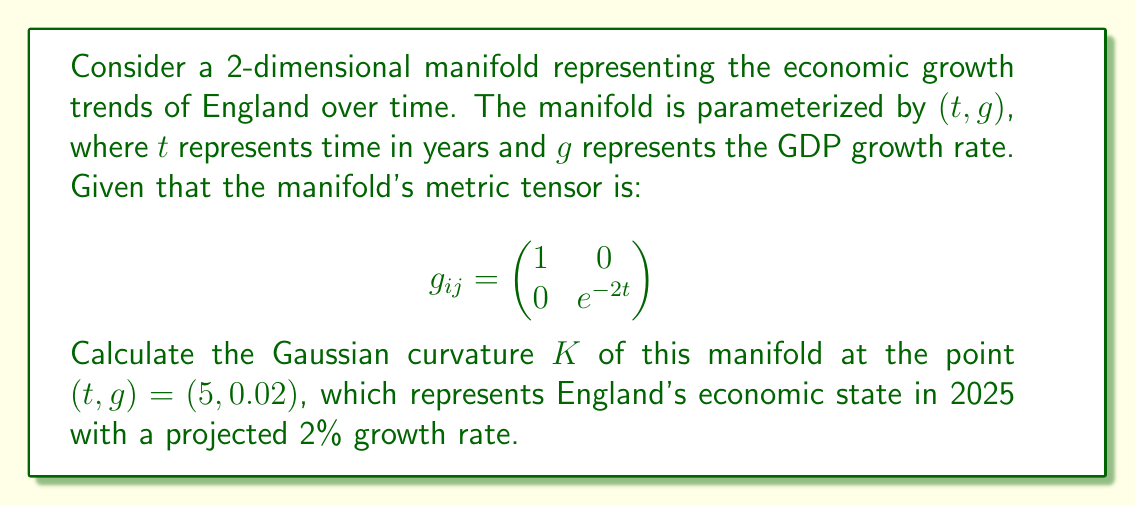Can you answer this question? To calculate the Gaussian curvature of the manifold, we'll follow these steps:

1) The Gaussian curvature $K$ is given by:

   $$K = \frac{R_{1212}}{g}$$

   where $R_{1212}$ is the only non-zero component of the Riemann curvature tensor for a 2D manifold, and $g$ is the determinant of the metric tensor.

2) First, let's calculate the determinant of the metric tensor:

   $$g = \det(g_{ij}) = 1 \cdot e^{-2t} = e^{-2t}$$

3) To find $R_{1212}$, we need to calculate the Christoffel symbols:

   $$\Gamma^k_{ij} = \frac{1}{2}g^{kl}(\partial_i g_{jl} + \partial_j g_{il} - \partial_l g_{ij})$$

4) The non-zero Christoffel symbols are:

   $$\Gamma^2_{12} = \Gamma^2_{21} = -1$$

5) Now we can calculate $R_{1212}$:

   $$R_{1212} = \partial_1 \Gamma^2_{22} - \partial_2 \Gamma^2_{12} + \Gamma^2_{12}\Gamma^2_{21} - \Gamma^2_{22}\Gamma^2_{11}$$

   $$R_{1212} = 0 - 0 + (-1)(-1) - 0 = 1$$

6) Therefore, the Gaussian curvature is:

   $$K = \frac{R_{1212}}{g} = \frac{1}{e^{-2t}} = e^{2t}$$

7) At the point $(t, g) = (5, 0.02)$, we have:

   $$K = e^{2(5)} = e^{10}$$

This high positive curvature indicates a rapidly changing economic landscape, which aligns with the historical volatility of England's economy.
Answer: The Gaussian curvature of the economic growth trends manifold at $(t, g) = (5, 0.02)$ is $K = e^{10} \approx 22,026.47$. 